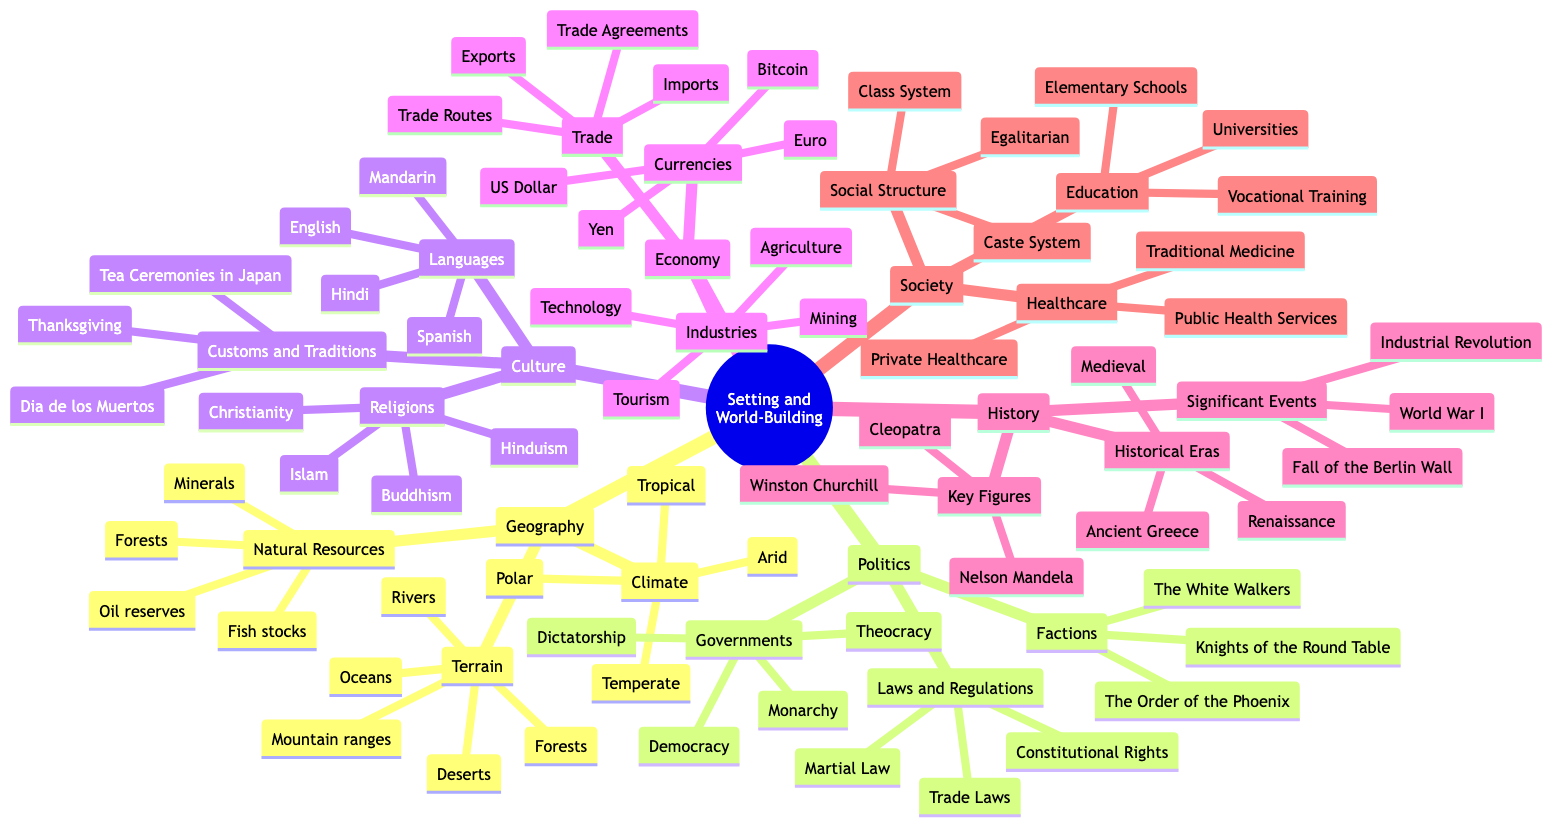What are the three terrains listed in the Geography section? To find the answer, look under the "Geography" category, specifically the "Terrain" subcategory. The diagram lists "Mountain ranges," "Deserts," and "Forests" as part of this group.
Answer: Mountain ranges, Deserts, Forests How many languages are mentioned in the Culture section? Under the "Culture" category, there is a subcategory named "Languages." The diagram lists four specific languages: "English," "Mandarin," "Spanish," and "Hindi." Therefore, the total count is four.
Answer: 4 What type of government is not listed under Politics? To answer this, we need to identify the types of governments in the "Politics" section. The diagram lists "Democracy," "Monarchy," "Theocracy," and "Dictatorship," indicating that any other form, such as "Communism," is not mentioned.
Answer: Communism Which historical event is categorized under History? Within the "History" section, there is a subcategory labeled "Significant Events," which includes "World War I," "Industrial Revolution," and "Fall of the Berlin Wall." Thus, any of these events can serve as an example.
Answer: World War I What are the three main industries found in the Economy section? In the "Economy" category, there is a subcategory called "Industries," where "Technology," "Agriculture," and "Mining" are explicitly listed. Therefore, these three are among the main industries highlighted.
Answer: Technology, Agriculture, Mining Which society structure is specifically categorized as "Egalitarian"? Looking under the "Society" category, in the subcategory "Social Structure," the term "Egalitarian" is included, indicating one of the possible structures of society discussed in the diagram.
Answer: Egalitarian What resource is found under Geography but not under Economy? In the "Geography" section, "Natural Resources" includes "Minerals," "Forests," "Fish stocks," and "Oil reserves." In contrast, the "Economy" does not list "Fish stocks" as a resource, thus making it unique to Geography.
Answer: Fish stocks How many religions are mentioned in the Culture section? The "Culture" category contains a subcategory titled "Religions," which mentions "Christianity," "Islam," "Hinduism," and "Buddhism." This totals to four distinct religions highlighted in the diagram.
Answer: 4 